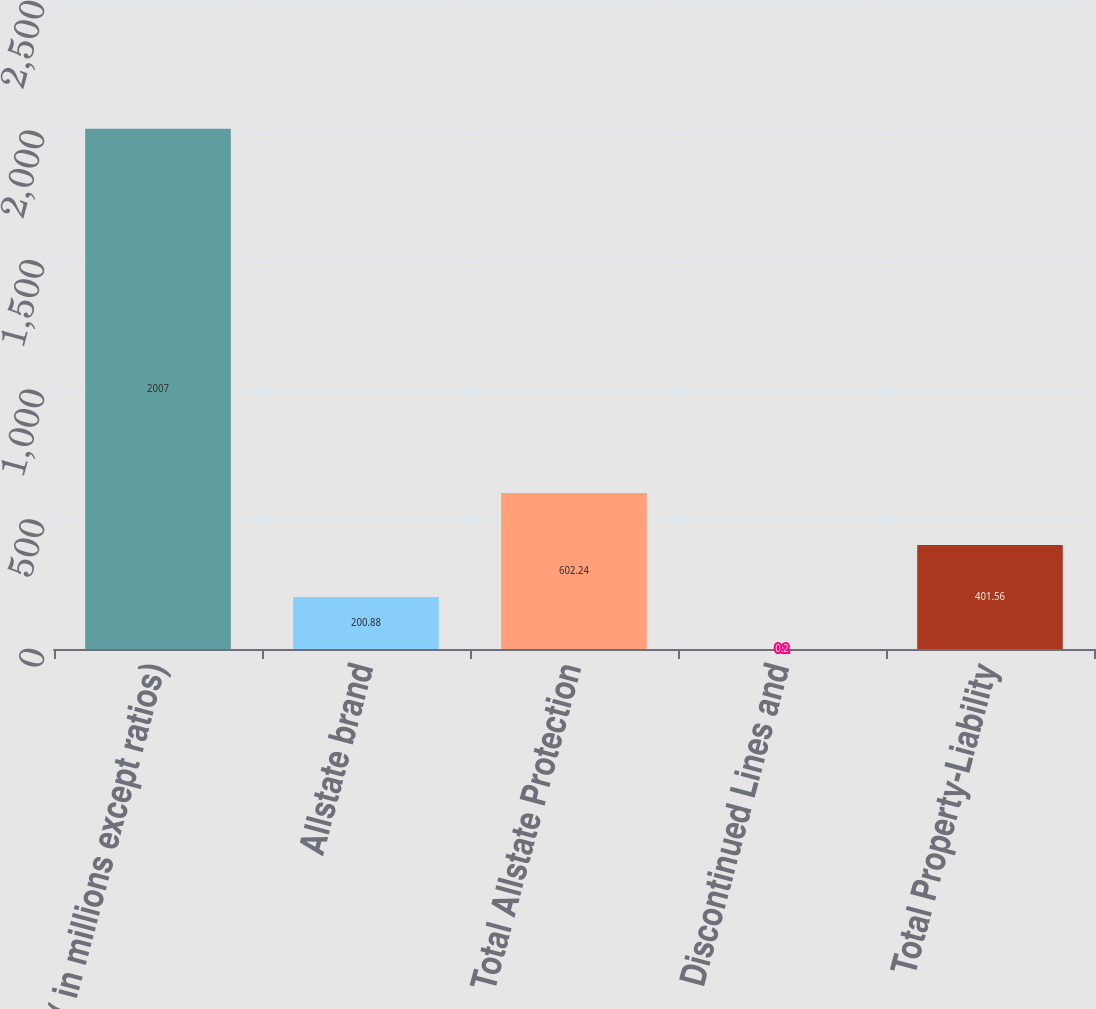Convert chart. <chart><loc_0><loc_0><loc_500><loc_500><bar_chart><fcel>( in millions except ratios)<fcel>Allstate brand<fcel>Total Allstate Protection<fcel>Discontinued Lines and<fcel>Total Property-Liability<nl><fcel>2007<fcel>200.88<fcel>602.24<fcel>0.2<fcel>401.56<nl></chart> 